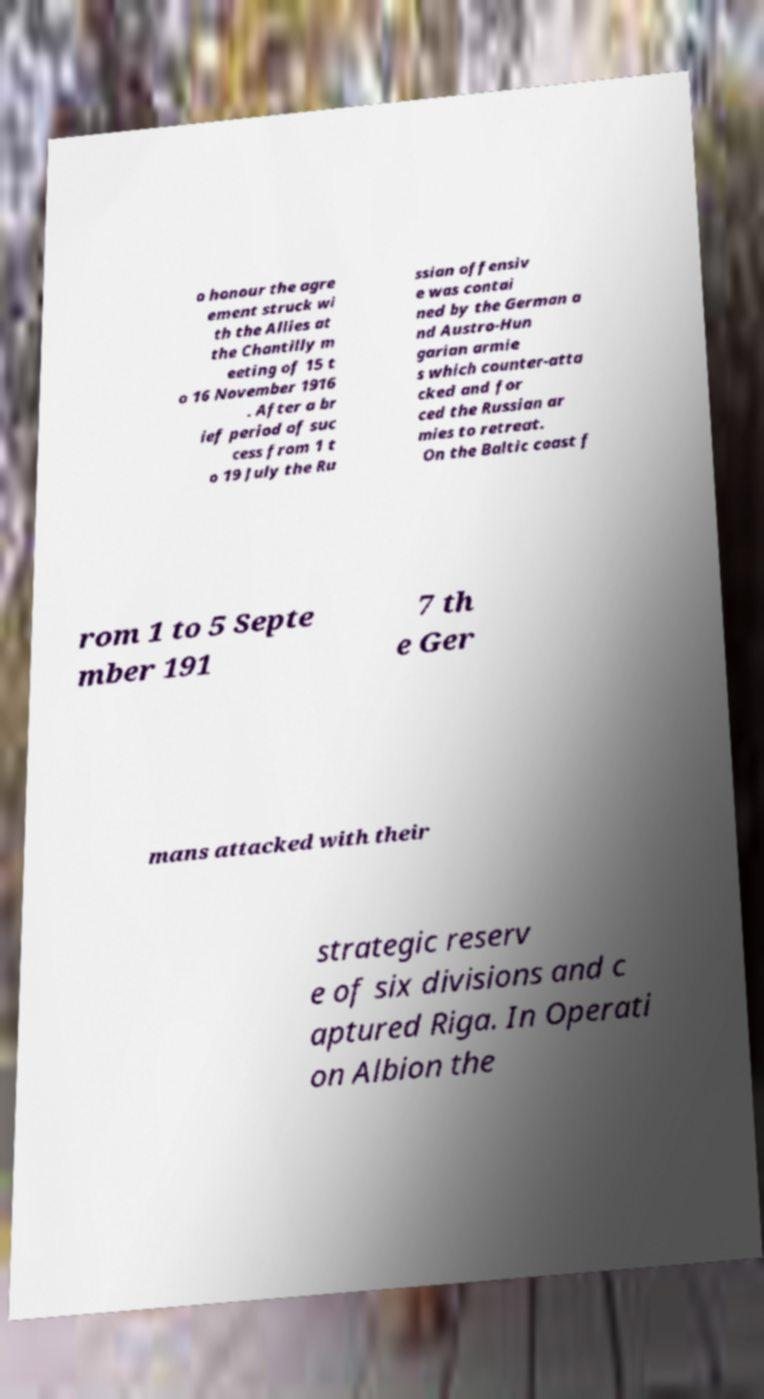For documentation purposes, I need the text within this image transcribed. Could you provide that? o honour the agre ement struck wi th the Allies at the Chantilly m eeting of 15 t o 16 November 1916 . After a br ief period of suc cess from 1 t o 19 July the Ru ssian offensiv e was contai ned by the German a nd Austro-Hun garian armie s which counter-atta cked and for ced the Russian ar mies to retreat. On the Baltic coast f rom 1 to 5 Septe mber 191 7 th e Ger mans attacked with their strategic reserv e of six divisions and c aptured Riga. In Operati on Albion the 